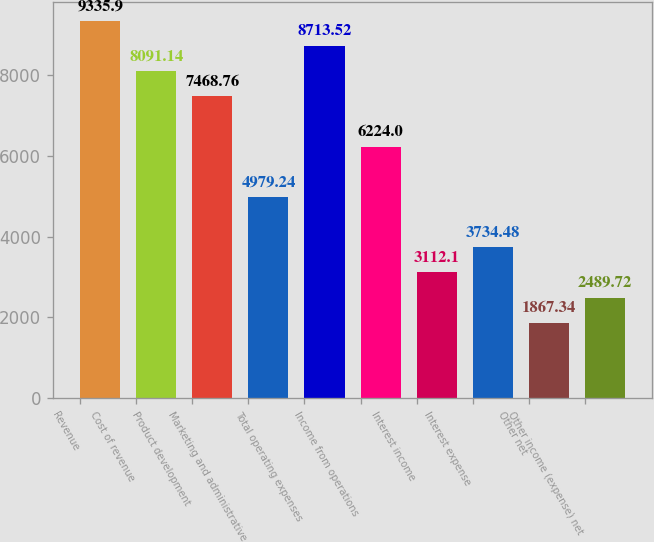<chart> <loc_0><loc_0><loc_500><loc_500><bar_chart><fcel>Revenue<fcel>Cost of revenue<fcel>Product development<fcel>Marketing and administrative<fcel>Total operating expenses<fcel>Income from operations<fcel>Interest income<fcel>Interest expense<fcel>Other net<fcel>Other income (expense) net<nl><fcel>9335.9<fcel>8091.14<fcel>7468.76<fcel>4979.24<fcel>8713.52<fcel>6224<fcel>3112.1<fcel>3734.48<fcel>1867.34<fcel>2489.72<nl></chart> 